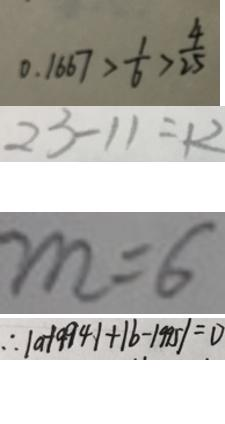Convert formula to latex. <formula><loc_0><loc_0><loc_500><loc_500>0 . 1 6 6 7 > \frac { 1 } { 6 } > \frac { 4 } { 2 5 } 
 2 3 - 1 1 = 1 2 
 m = 6 
 \therefore \vert a - 1 9 9 4 \vert + \vert b - 1 9 9 5 \vert = 0</formula> 